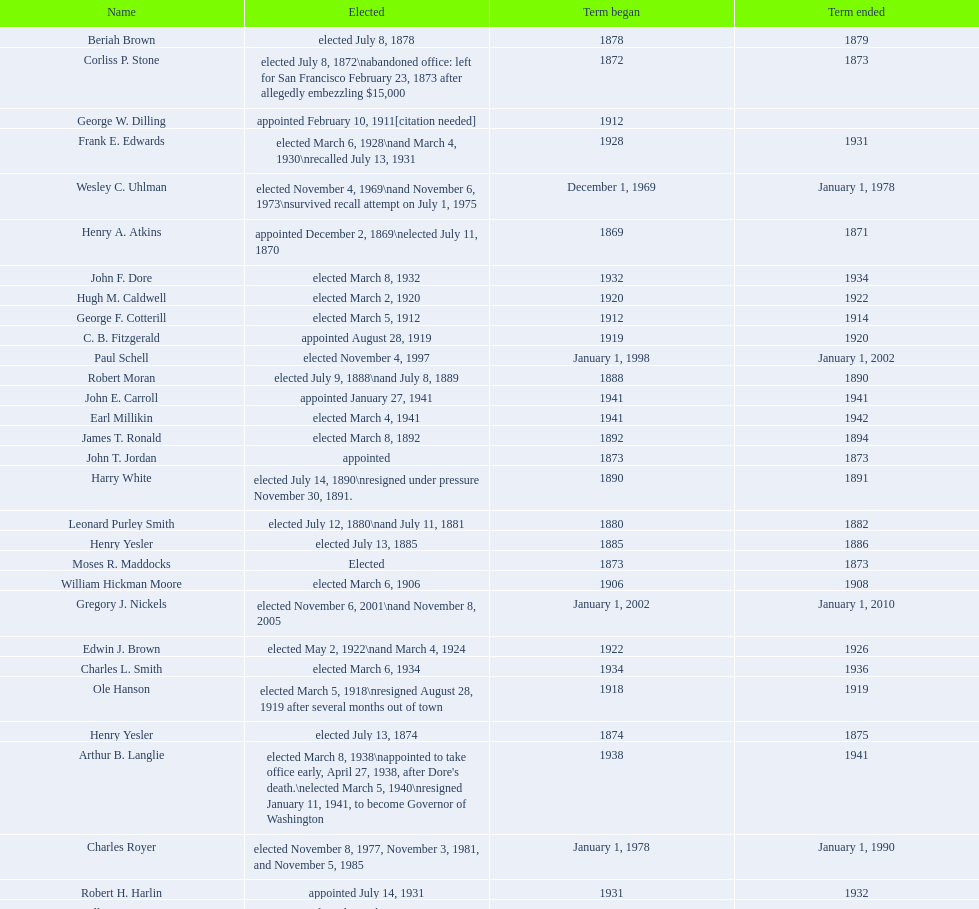Parse the full table. {'header': ['Name', 'Elected', 'Term began', 'Term ended'], 'rows': [['Beriah Brown', 'elected July 8, 1878', '1878', '1879'], ['Corliss P. Stone', 'elected July 8, 1872\\nabandoned office: left for San Francisco February 23, 1873 after allegedly embezzling $15,000', '1872', '1873'], ['George W. Dilling', 'appointed February 10, 1911[citation needed]', '1912', ''], ['Frank E. Edwards', 'elected March 6, 1928\\nand March 4, 1930\\nrecalled July 13, 1931', '1928', '1931'], ['Wesley C. Uhlman', 'elected November 4, 1969\\nand November 6, 1973\\nsurvived recall attempt on July 1, 1975', 'December 1, 1969', 'January 1, 1978'], ['Henry A. Atkins', 'appointed December 2, 1869\\nelected July 11, 1870', '1869', '1871'], ['John F. Dore', 'elected March 8, 1932', '1932', '1934'], ['Hugh M. Caldwell', 'elected March 2, 1920', '1920', '1922'], ['George F. Cotterill', 'elected March 5, 1912', '1912', '1914'], ['C. B. Fitzgerald', 'appointed August 28, 1919', '1919', '1920'], ['Paul Schell', 'elected November 4, 1997', 'January 1, 1998', 'January 1, 2002'], ['Robert Moran', 'elected July 9, 1888\\nand July 8, 1889', '1888', '1890'], ['John E. Carroll', 'appointed January 27, 1941', '1941', '1941'], ['Earl Millikin', 'elected March 4, 1941', '1941', '1942'], ['James T. Ronald', 'elected March 8, 1892', '1892', '1894'], ['John T. Jordan', 'appointed', '1873', '1873'], ['Harry White', 'elected July 14, 1890\\nresigned under pressure November 30, 1891.', '1890', '1891'], ['Leonard Purley Smith', 'elected July 12, 1880\\nand July 11, 1881', '1880', '1882'], ['Henry Yesler', 'elected July 13, 1885', '1885', '1886'], ['Moses R. Maddocks', 'Elected', '1873', '1873'], ['William Hickman Moore', 'elected March 6, 1906', '1906', '1908'], ['Gregory J. Nickels', 'elected November 6, 2001\\nand November 8, 2005', 'January 1, 2002', 'January 1, 2010'], ['Edwin J. Brown', 'elected May 2, 1922\\nand March 4, 1924', '1922', '1926'], ['Charles L. Smith', 'elected March 6, 1934', '1934', '1936'], ['Ole Hanson', 'elected March 5, 1918\\nresigned August 28, 1919 after several months out of town', '1918', '1919'], ['Henry Yesler', 'elected July 13, 1874', '1874', '1875'], ['Arthur B. Langlie', "elected March 8, 1938\\nappointed to take office early, April 27, 1938, after Dore's death.\\nelected March 5, 1940\\nresigned January 11, 1941, to become Governor of Washington", '1938', '1941'], ['Charles Royer', 'elected November 8, 1977, November 3, 1981, and November 5, 1985', 'January 1, 1978', 'January 1, 1990'], ['Robert H. Harlin', 'appointed July 14, 1931', '1931', '1932'], ['Allan Pomeroy', 'elected March 4, 1952', '1952', '1956'], ['Gordon S. Clinton', 'elected March 6, 1956\\nand March 8, 1960', '1956', '1964'], ['John F. Dore', 'elected March 3, 1936\\nbecame gravely ill and was relieved of office April 13, 1938, already a lame duck after the 1938 election. He died five days later.', '1936', '1938'], ['John Leary', 'elected July 14, 1884', '1884', '1885'], ['Frank D. Black', 'elected March 9, 1896\\nresigned after three weeks in office', '1896', '1896'], ['Hiram C. Gill', 'elected March 8, 1910\\nrecalled February 9, 1911', '1910', '1911'], ['Ed Murray', 'elected November 5, 2013', 'January 1, 2014', 'present'], ['John F. Miller', 'elected March 3, 1908', '1908', '1910'], ['Thomas J. Humes', 'appointed November 19, 1897\\nand elected March 13, 1900', '1897', '1904'], ['Hiram C. Gill', 'elected March 3, 1914', '1914', '1918'], ['Richard A. Ballinger', 'elected March 8, 1904', '1904', '1906'], ['Michael McGinn', 'elected November 3, 2009', 'January 1, 2010', 'January 1, 2014'], ['Henry G. Struve', 'elected July 10, 1882\\nand July 9, 1883', '1882', '1884'], ["James d'Orma Braman", 'elected March 10, 1964\\nresigned March 23, 1969, to accept an appointment as an Assistant Secretary in the Department of Transportation in the Nixon administration.', '1964', '1969'], ['William F. Devin', 'elected March 3, 1942, March 7, 1944, March 5, 1946, and March 2, 1948', '1942', '1952'], ['Gideon A. Weed', 'elected July 10, 1876\\nand July 9, 1877', '1876', '1878'], ['George W. Hall', 'appointed December 9, 1891', '1891', '1892'], ['John T. Jordan', 'elected July 10, 1871', '1871', '1872'], ['Bailey Gatzert', 'elected August 2, 1875', '1875', '1876'], ['John Collins', 'elected July 14, 1873', '1873', '1874'], ['Orange Jacobs', 'elected July 14, 1879', '1879', '1880'], ['Floyd C. Miller', 'appointed March 23, 1969', '1969', '1969'], ['W. D. Wood', 'appointed April 6, 1896\\nresigned July 1897', '1896', '1897'], ['Bertha Knight Landes', 'elected March 9, 1926', '1926', '1928'], ['William H. Shoudy', 'elected July 12, 1886', '1886', '1887'], ['Dr. Thomas T. Minor', 'elected July 11, 1887', '1887', '1888'], ['Norman B. Rice', 'elected November 7, 1989', 'January 1, 1990', 'January 1, 1998'], ['Byron Phelps', 'elected March 12, 1894', '1894', '1896']]} Who was the mayor before jordan? Henry A. Atkins. 